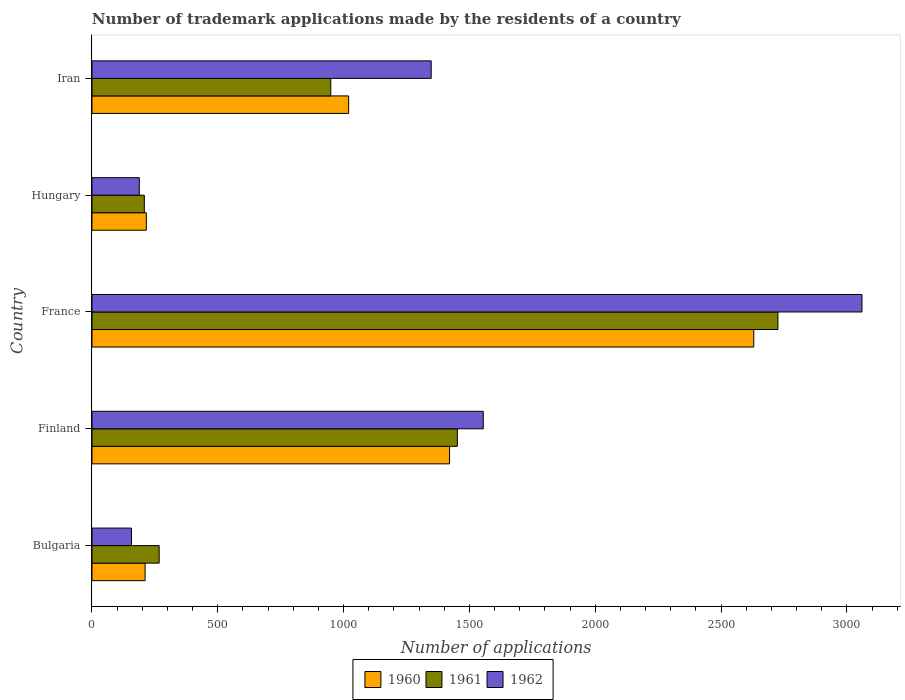How many groups of bars are there?
Offer a very short reply. 5. Are the number of bars on each tick of the Y-axis equal?
Your response must be concise. Yes. How many bars are there on the 4th tick from the top?
Your response must be concise. 3. What is the number of trademark applications made by the residents in 1960 in Bulgaria?
Ensure brevity in your answer.  211. Across all countries, what is the maximum number of trademark applications made by the residents in 1960?
Offer a very short reply. 2630. Across all countries, what is the minimum number of trademark applications made by the residents in 1960?
Keep it short and to the point. 211. In which country was the number of trademark applications made by the residents in 1960 maximum?
Your response must be concise. France. What is the total number of trademark applications made by the residents in 1961 in the graph?
Provide a succinct answer. 5602. What is the difference between the number of trademark applications made by the residents in 1960 in Bulgaria and that in Finland?
Ensure brevity in your answer.  -1210. What is the difference between the number of trademark applications made by the residents in 1962 in Bulgaria and the number of trademark applications made by the residents in 1960 in Hungary?
Your answer should be very brief. -59. What is the average number of trademark applications made by the residents in 1962 per country?
Provide a succinct answer. 1261.6. What is the difference between the number of trademark applications made by the residents in 1960 and number of trademark applications made by the residents in 1961 in France?
Your response must be concise. -96. In how many countries, is the number of trademark applications made by the residents in 1960 greater than 1800 ?
Offer a terse response. 1. What is the ratio of the number of trademark applications made by the residents in 1960 in Finland to that in Hungary?
Your response must be concise. 6.58. What is the difference between the highest and the second highest number of trademark applications made by the residents in 1960?
Your answer should be compact. 1209. What is the difference between the highest and the lowest number of trademark applications made by the residents in 1962?
Your answer should be compact. 2903. In how many countries, is the number of trademark applications made by the residents in 1960 greater than the average number of trademark applications made by the residents in 1960 taken over all countries?
Give a very brief answer. 2. What does the 1st bar from the top in Iran represents?
Provide a succinct answer. 1962. How many bars are there?
Provide a short and direct response. 15. Are the values on the major ticks of X-axis written in scientific E-notation?
Your response must be concise. No. Does the graph contain any zero values?
Provide a short and direct response. No. How many legend labels are there?
Provide a succinct answer. 3. How are the legend labels stacked?
Provide a succinct answer. Horizontal. What is the title of the graph?
Provide a succinct answer. Number of trademark applications made by the residents of a country. What is the label or title of the X-axis?
Offer a terse response. Number of applications. What is the label or title of the Y-axis?
Provide a short and direct response. Country. What is the Number of applications in 1960 in Bulgaria?
Ensure brevity in your answer.  211. What is the Number of applications of 1961 in Bulgaria?
Make the answer very short. 267. What is the Number of applications in 1962 in Bulgaria?
Your response must be concise. 157. What is the Number of applications of 1960 in Finland?
Offer a terse response. 1421. What is the Number of applications of 1961 in Finland?
Your response must be concise. 1452. What is the Number of applications in 1962 in Finland?
Provide a succinct answer. 1555. What is the Number of applications of 1960 in France?
Your answer should be very brief. 2630. What is the Number of applications in 1961 in France?
Provide a short and direct response. 2726. What is the Number of applications of 1962 in France?
Give a very brief answer. 3060. What is the Number of applications of 1960 in Hungary?
Give a very brief answer. 216. What is the Number of applications of 1961 in Hungary?
Your answer should be very brief. 208. What is the Number of applications of 1962 in Hungary?
Provide a short and direct response. 188. What is the Number of applications in 1960 in Iran?
Keep it short and to the point. 1020. What is the Number of applications of 1961 in Iran?
Offer a terse response. 949. What is the Number of applications of 1962 in Iran?
Offer a very short reply. 1348. Across all countries, what is the maximum Number of applications of 1960?
Your answer should be compact. 2630. Across all countries, what is the maximum Number of applications in 1961?
Offer a very short reply. 2726. Across all countries, what is the maximum Number of applications in 1962?
Give a very brief answer. 3060. Across all countries, what is the minimum Number of applications of 1960?
Your answer should be very brief. 211. Across all countries, what is the minimum Number of applications in 1961?
Your answer should be compact. 208. Across all countries, what is the minimum Number of applications in 1962?
Make the answer very short. 157. What is the total Number of applications of 1960 in the graph?
Offer a very short reply. 5498. What is the total Number of applications in 1961 in the graph?
Offer a very short reply. 5602. What is the total Number of applications in 1962 in the graph?
Keep it short and to the point. 6308. What is the difference between the Number of applications of 1960 in Bulgaria and that in Finland?
Offer a very short reply. -1210. What is the difference between the Number of applications in 1961 in Bulgaria and that in Finland?
Make the answer very short. -1185. What is the difference between the Number of applications of 1962 in Bulgaria and that in Finland?
Provide a succinct answer. -1398. What is the difference between the Number of applications of 1960 in Bulgaria and that in France?
Your answer should be compact. -2419. What is the difference between the Number of applications of 1961 in Bulgaria and that in France?
Your answer should be compact. -2459. What is the difference between the Number of applications in 1962 in Bulgaria and that in France?
Give a very brief answer. -2903. What is the difference between the Number of applications of 1961 in Bulgaria and that in Hungary?
Your answer should be very brief. 59. What is the difference between the Number of applications in 1962 in Bulgaria and that in Hungary?
Provide a succinct answer. -31. What is the difference between the Number of applications of 1960 in Bulgaria and that in Iran?
Keep it short and to the point. -809. What is the difference between the Number of applications of 1961 in Bulgaria and that in Iran?
Your answer should be compact. -682. What is the difference between the Number of applications in 1962 in Bulgaria and that in Iran?
Provide a succinct answer. -1191. What is the difference between the Number of applications of 1960 in Finland and that in France?
Your response must be concise. -1209. What is the difference between the Number of applications in 1961 in Finland and that in France?
Ensure brevity in your answer.  -1274. What is the difference between the Number of applications of 1962 in Finland and that in France?
Give a very brief answer. -1505. What is the difference between the Number of applications of 1960 in Finland and that in Hungary?
Ensure brevity in your answer.  1205. What is the difference between the Number of applications in 1961 in Finland and that in Hungary?
Provide a succinct answer. 1244. What is the difference between the Number of applications of 1962 in Finland and that in Hungary?
Make the answer very short. 1367. What is the difference between the Number of applications in 1960 in Finland and that in Iran?
Your answer should be compact. 401. What is the difference between the Number of applications of 1961 in Finland and that in Iran?
Your answer should be compact. 503. What is the difference between the Number of applications in 1962 in Finland and that in Iran?
Provide a short and direct response. 207. What is the difference between the Number of applications in 1960 in France and that in Hungary?
Make the answer very short. 2414. What is the difference between the Number of applications of 1961 in France and that in Hungary?
Give a very brief answer. 2518. What is the difference between the Number of applications of 1962 in France and that in Hungary?
Offer a terse response. 2872. What is the difference between the Number of applications in 1960 in France and that in Iran?
Provide a succinct answer. 1610. What is the difference between the Number of applications in 1961 in France and that in Iran?
Your response must be concise. 1777. What is the difference between the Number of applications of 1962 in France and that in Iran?
Give a very brief answer. 1712. What is the difference between the Number of applications of 1960 in Hungary and that in Iran?
Make the answer very short. -804. What is the difference between the Number of applications of 1961 in Hungary and that in Iran?
Make the answer very short. -741. What is the difference between the Number of applications in 1962 in Hungary and that in Iran?
Provide a short and direct response. -1160. What is the difference between the Number of applications in 1960 in Bulgaria and the Number of applications in 1961 in Finland?
Provide a succinct answer. -1241. What is the difference between the Number of applications of 1960 in Bulgaria and the Number of applications of 1962 in Finland?
Offer a very short reply. -1344. What is the difference between the Number of applications of 1961 in Bulgaria and the Number of applications of 1962 in Finland?
Give a very brief answer. -1288. What is the difference between the Number of applications in 1960 in Bulgaria and the Number of applications in 1961 in France?
Give a very brief answer. -2515. What is the difference between the Number of applications in 1960 in Bulgaria and the Number of applications in 1962 in France?
Your response must be concise. -2849. What is the difference between the Number of applications in 1961 in Bulgaria and the Number of applications in 1962 in France?
Offer a very short reply. -2793. What is the difference between the Number of applications in 1960 in Bulgaria and the Number of applications in 1961 in Hungary?
Your response must be concise. 3. What is the difference between the Number of applications in 1960 in Bulgaria and the Number of applications in 1962 in Hungary?
Offer a very short reply. 23. What is the difference between the Number of applications in 1961 in Bulgaria and the Number of applications in 1962 in Hungary?
Your answer should be compact. 79. What is the difference between the Number of applications of 1960 in Bulgaria and the Number of applications of 1961 in Iran?
Make the answer very short. -738. What is the difference between the Number of applications of 1960 in Bulgaria and the Number of applications of 1962 in Iran?
Ensure brevity in your answer.  -1137. What is the difference between the Number of applications in 1961 in Bulgaria and the Number of applications in 1962 in Iran?
Provide a short and direct response. -1081. What is the difference between the Number of applications of 1960 in Finland and the Number of applications of 1961 in France?
Your answer should be compact. -1305. What is the difference between the Number of applications in 1960 in Finland and the Number of applications in 1962 in France?
Provide a short and direct response. -1639. What is the difference between the Number of applications in 1961 in Finland and the Number of applications in 1962 in France?
Offer a terse response. -1608. What is the difference between the Number of applications of 1960 in Finland and the Number of applications of 1961 in Hungary?
Your answer should be compact. 1213. What is the difference between the Number of applications in 1960 in Finland and the Number of applications in 1962 in Hungary?
Your response must be concise. 1233. What is the difference between the Number of applications in 1961 in Finland and the Number of applications in 1962 in Hungary?
Give a very brief answer. 1264. What is the difference between the Number of applications of 1960 in Finland and the Number of applications of 1961 in Iran?
Your answer should be very brief. 472. What is the difference between the Number of applications in 1960 in Finland and the Number of applications in 1962 in Iran?
Provide a short and direct response. 73. What is the difference between the Number of applications of 1961 in Finland and the Number of applications of 1962 in Iran?
Provide a succinct answer. 104. What is the difference between the Number of applications of 1960 in France and the Number of applications of 1961 in Hungary?
Give a very brief answer. 2422. What is the difference between the Number of applications of 1960 in France and the Number of applications of 1962 in Hungary?
Offer a very short reply. 2442. What is the difference between the Number of applications of 1961 in France and the Number of applications of 1962 in Hungary?
Your answer should be very brief. 2538. What is the difference between the Number of applications in 1960 in France and the Number of applications in 1961 in Iran?
Give a very brief answer. 1681. What is the difference between the Number of applications of 1960 in France and the Number of applications of 1962 in Iran?
Make the answer very short. 1282. What is the difference between the Number of applications in 1961 in France and the Number of applications in 1962 in Iran?
Your response must be concise. 1378. What is the difference between the Number of applications in 1960 in Hungary and the Number of applications in 1961 in Iran?
Your response must be concise. -733. What is the difference between the Number of applications in 1960 in Hungary and the Number of applications in 1962 in Iran?
Provide a short and direct response. -1132. What is the difference between the Number of applications in 1961 in Hungary and the Number of applications in 1962 in Iran?
Make the answer very short. -1140. What is the average Number of applications in 1960 per country?
Give a very brief answer. 1099.6. What is the average Number of applications in 1961 per country?
Ensure brevity in your answer.  1120.4. What is the average Number of applications in 1962 per country?
Keep it short and to the point. 1261.6. What is the difference between the Number of applications in 1960 and Number of applications in 1961 in Bulgaria?
Offer a very short reply. -56. What is the difference between the Number of applications of 1960 and Number of applications of 1962 in Bulgaria?
Offer a terse response. 54. What is the difference between the Number of applications in 1961 and Number of applications in 1962 in Bulgaria?
Provide a short and direct response. 110. What is the difference between the Number of applications of 1960 and Number of applications of 1961 in Finland?
Keep it short and to the point. -31. What is the difference between the Number of applications in 1960 and Number of applications in 1962 in Finland?
Provide a succinct answer. -134. What is the difference between the Number of applications in 1961 and Number of applications in 1962 in Finland?
Your response must be concise. -103. What is the difference between the Number of applications of 1960 and Number of applications of 1961 in France?
Give a very brief answer. -96. What is the difference between the Number of applications in 1960 and Number of applications in 1962 in France?
Your answer should be very brief. -430. What is the difference between the Number of applications in 1961 and Number of applications in 1962 in France?
Offer a very short reply. -334. What is the difference between the Number of applications of 1960 and Number of applications of 1962 in Hungary?
Offer a terse response. 28. What is the difference between the Number of applications in 1960 and Number of applications in 1961 in Iran?
Provide a succinct answer. 71. What is the difference between the Number of applications of 1960 and Number of applications of 1962 in Iran?
Provide a succinct answer. -328. What is the difference between the Number of applications of 1961 and Number of applications of 1962 in Iran?
Your answer should be compact. -399. What is the ratio of the Number of applications of 1960 in Bulgaria to that in Finland?
Make the answer very short. 0.15. What is the ratio of the Number of applications in 1961 in Bulgaria to that in Finland?
Ensure brevity in your answer.  0.18. What is the ratio of the Number of applications in 1962 in Bulgaria to that in Finland?
Give a very brief answer. 0.1. What is the ratio of the Number of applications of 1960 in Bulgaria to that in France?
Provide a succinct answer. 0.08. What is the ratio of the Number of applications of 1961 in Bulgaria to that in France?
Your answer should be compact. 0.1. What is the ratio of the Number of applications of 1962 in Bulgaria to that in France?
Keep it short and to the point. 0.05. What is the ratio of the Number of applications in 1960 in Bulgaria to that in Hungary?
Offer a terse response. 0.98. What is the ratio of the Number of applications in 1961 in Bulgaria to that in Hungary?
Offer a terse response. 1.28. What is the ratio of the Number of applications in 1962 in Bulgaria to that in Hungary?
Ensure brevity in your answer.  0.84. What is the ratio of the Number of applications in 1960 in Bulgaria to that in Iran?
Make the answer very short. 0.21. What is the ratio of the Number of applications in 1961 in Bulgaria to that in Iran?
Keep it short and to the point. 0.28. What is the ratio of the Number of applications of 1962 in Bulgaria to that in Iran?
Ensure brevity in your answer.  0.12. What is the ratio of the Number of applications of 1960 in Finland to that in France?
Ensure brevity in your answer.  0.54. What is the ratio of the Number of applications in 1961 in Finland to that in France?
Make the answer very short. 0.53. What is the ratio of the Number of applications of 1962 in Finland to that in France?
Give a very brief answer. 0.51. What is the ratio of the Number of applications in 1960 in Finland to that in Hungary?
Offer a terse response. 6.58. What is the ratio of the Number of applications in 1961 in Finland to that in Hungary?
Ensure brevity in your answer.  6.98. What is the ratio of the Number of applications of 1962 in Finland to that in Hungary?
Ensure brevity in your answer.  8.27. What is the ratio of the Number of applications of 1960 in Finland to that in Iran?
Make the answer very short. 1.39. What is the ratio of the Number of applications in 1961 in Finland to that in Iran?
Offer a terse response. 1.53. What is the ratio of the Number of applications of 1962 in Finland to that in Iran?
Provide a succinct answer. 1.15. What is the ratio of the Number of applications of 1960 in France to that in Hungary?
Your answer should be very brief. 12.18. What is the ratio of the Number of applications in 1961 in France to that in Hungary?
Ensure brevity in your answer.  13.11. What is the ratio of the Number of applications of 1962 in France to that in Hungary?
Give a very brief answer. 16.28. What is the ratio of the Number of applications of 1960 in France to that in Iran?
Provide a short and direct response. 2.58. What is the ratio of the Number of applications of 1961 in France to that in Iran?
Ensure brevity in your answer.  2.87. What is the ratio of the Number of applications in 1962 in France to that in Iran?
Your answer should be very brief. 2.27. What is the ratio of the Number of applications in 1960 in Hungary to that in Iran?
Offer a terse response. 0.21. What is the ratio of the Number of applications of 1961 in Hungary to that in Iran?
Your answer should be compact. 0.22. What is the ratio of the Number of applications of 1962 in Hungary to that in Iran?
Offer a very short reply. 0.14. What is the difference between the highest and the second highest Number of applications in 1960?
Offer a very short reply. 1209. What is the difference between the highest and the second highest Number of applications in 1961?
Offer a terse response. 1274. What is the difference between the highest and the second highest Number of applications in 1962?
Offer a very short reply. 1505. What is the difference between the highest and the lowest Number of applications of 1960?
Your response must be concise. 2419. What is the difference between the highest and the lowest Number of applications of 1961?
Your answer should be very brief. 2518. What is the difference between the highest and the lowest Number of applications in 1962?
Your answer should be very brief. 2903. 